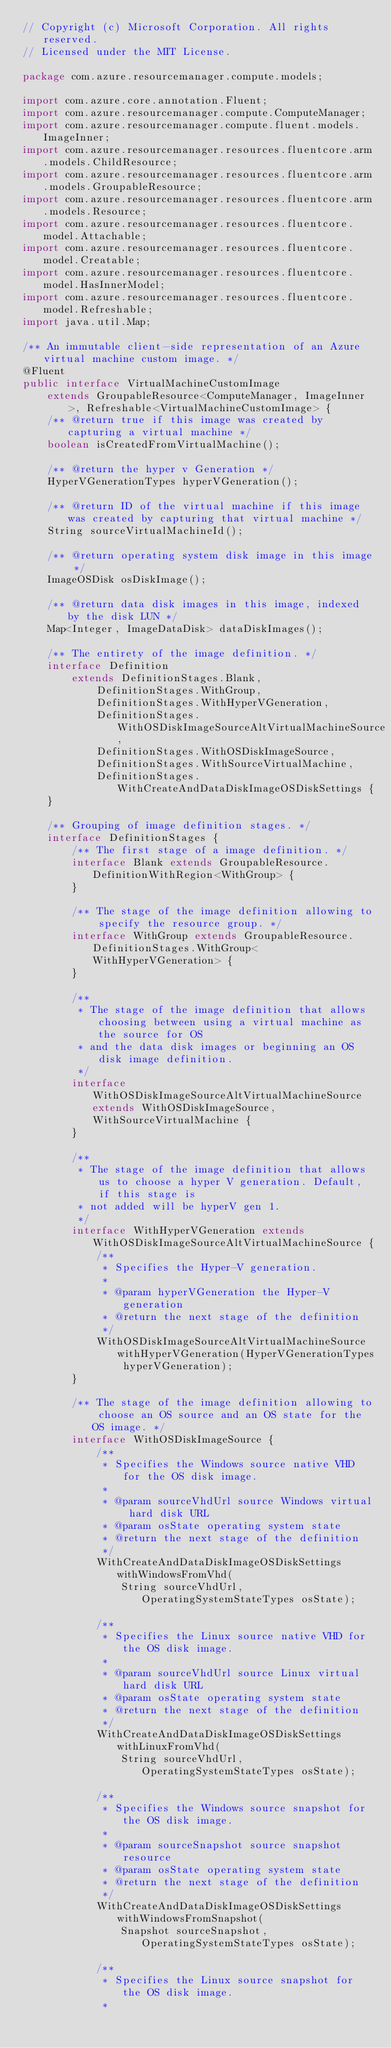Convert code to text. <code><loc_0><loc_0><loc_500><loc_500><_Java_>// Copyright (c) Microsoft Corporation. All rights reserved.
// Licensed under the MIT License.

package com.azure.resourcemanager.compute.models;

import com.azure.core.annotation.Fluent;
import com.azure.resourcemanager.compute.ComputeManager;
import com.azure.resourcemanager.compute.fluent.models.ImageInner;
import com.azure.resourcemanager.resources.fluentcore.arm.models.ChildResource;
import com.azure.resourcemanager.resources.fluentcore.arm.models.GroupableResource;
import com.azure.resourcemanager.resources.fluentcore.arm.models.Resource;
import com.azure.resourcemanager.resources.fluentcore.model.Attachable;
import com.azure.resourcemanager.resources.fluentcore.model.Creatable;
import com.azure.resourcemanager.resources.fluentcore.model.HasInnerModel;
import com.azure.resourcemanager.resources.fluentcore.model.Refreshable;
import java.util.Map;

/** An immutable client-side representation of an Azure virtual machine custom image. */
@Fluent
public interface VirtualMachineCustomImage
    extends GroupableResource<ComputeManager, ImageInner>, Refreshable<VirtualMachineCustomImage> {
    /** @return true if this image was created by capturing a virtual machine */
    boolean isCreatedFromVirtualMachine();

    /** @return the hyper v Generation */
    HyperVGenerationTypes hyperVGeneration();

    /** @return ID of the virtual machine if this image was created by capturing that virtual machine */
    String sourceVirtualMachineId();

    /** @return operating system disk image in this image */
    ImageOSDisk osDiskImage();

    /** @return data disk images in this image, indexed by the disk LUN */
    Map<Integer, ImageDataDisk> dataDiskImages();

    /** The entirety of the image definition. */
    interface Definition
        extends DefinitionStages.Blank,
            DefinitionStages.WithGroup,
            DefinitionStages.WithHyperVGeneration,
            DefinitionStages.WithOSDiskImageSourceAltVirtualMachineSource,
            DefinitionStages.WithOSDiskImageSource,
            DefinitionStages.WithSourceVirtualMachine,
            DefinitionStages.WithCreateAndDataDiskImageOSDiskSettings {
    }

    /** Grouping of image definition stages. */
    interface DefinitionStages {
        /** The first stage of a image definition. */
        interface Blank extends GroupableResource.DefinitionWithRegion<WithGroup> {
        }

        /** The stage of the image definition allowing to specify the resource group. */
        interface WithGroup extends GroupableResource.DefinitionStages.WithGroup<WithHyperVGeneration> {
        }

        /**
         * The stage of the image definition that allows choosing between using a virtual machine as the source for OS
         * and the data disk images or beginning an OS disk image definition.
         */
        interface WithOSDiskImageSourceAltVirtualMachineSource extends WithOSDiskImageSource, WithSourceVirtualMachine {
        }

        /**
         * The stage of the image definition that allows us to choose a hyper V generation. Default, if this stage is
         * not added will be hyperV gen 1.
         */
        interface WithHyperVGeneration extends WithOSDiskImageSourceAltVirtualMachineSource {
            /**
             * Specifies the Hyper-V generation.
             *
             * @param hyperVGeneration the Hyper-V generation
             * @return the next stage of the definition
             */
            WithOSDiskImageSourceAltVirtualMachineSource withHyperVGeneration(HyperVGenerationTypes hyperVGeneration);
        }

        /** The stage of the image definition allowing to choose an OS source and an OS state for the OS image. */
        interface WithOSDiskImageSource {
            /**
             * Specifies the Windows source native VHD for the OS disk image.
             *
             * @param sourceVhdUrl source Windows virtual hard disk URL
             * @param osState operating system state
             * @return the next stage of the definition
             */
            WithCreateAndDataDiskImageOSDiskSettings withWindowsFromVhd(
                String sourceVhdUrl, OperatingSystemStateTypes osState);

            /**
             * Specifies the Linux source native VHD for the OS disk image.
             *
             * @param sourceVhdUrl source Linux virtual hard disk URL
             * @param osState operating system state
             * @return the next stage of the definition
             */
            WithCreateAndDataDiskImageOSDiskSettings withLinuxFromVhd(
                String sourceVhdUrl, OperatingSystemStateTypes osState);

            /**
             * Specifies the Windows source snapshot for the OS disk image.
             *
             * @param sourceSnapshot source snapshot resource
             * @param osState operating system state
             * @return the next stage of the definition
             */
            WithCreateAndDataDiskImageOSDiskSettings withWindowsFromSnapshot(
                Snapshot sourceSnapshot, OperatingSystemStateTypes osState);

            /**
             * Specifies the Linux source snapshot for the OS disk image.
             *</code> 